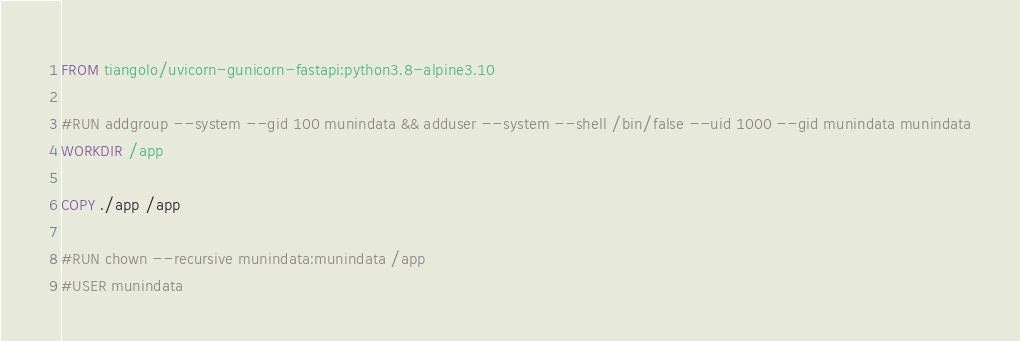<code> <loc_0><loc_0><loc_500><loc_500><_Dockerfile_>FROM tiangolo/uvicorn-gunicorn-fastapi:python3.8-alpine3.10

#RUN addgroup --system --gid 100 munindata && adduser --system --shell /bin/false --uid 1000 --gid munindata munindata
WORKDIR /app

COPY ./app /app

#RUN chown --recursive munindata:munindata /app
#USER munindata

</code> 